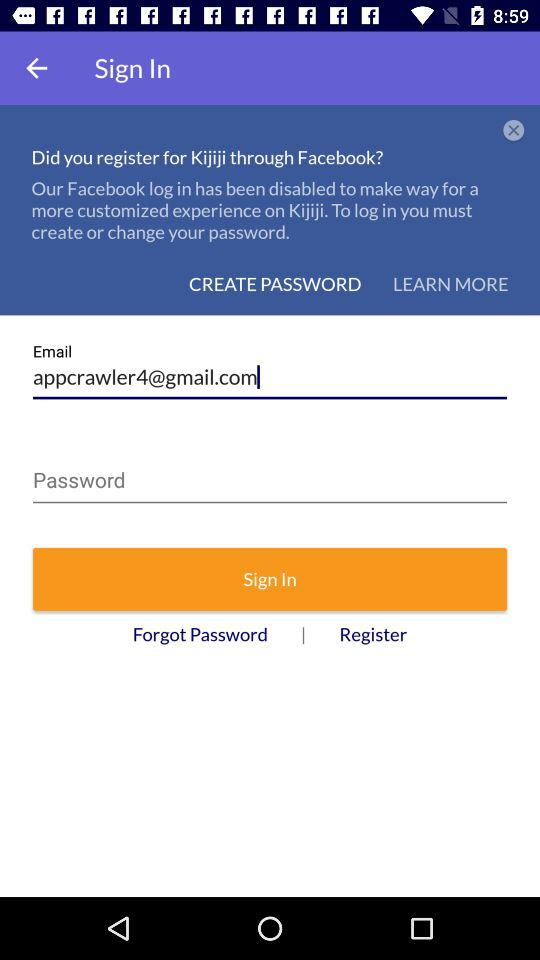What is the email address? The email address is appcrawler4@gmail.com. 